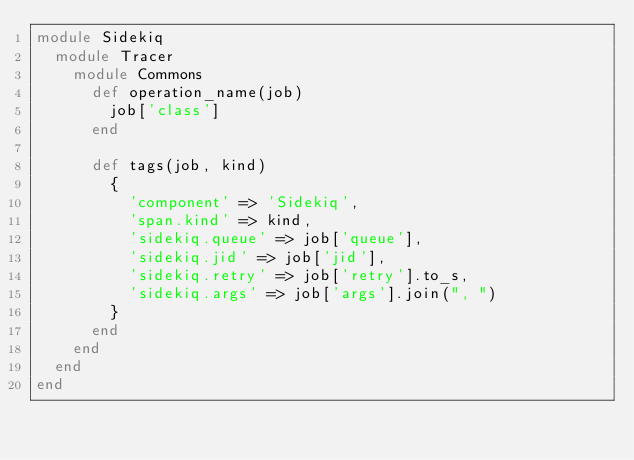<code> <loc_0><loc_0><loc_500><loc_500><_Ruby_>module Sidekiq
  module Tracer
    module Commons
      def operation_name(job)
        job['class']
      end

      def tags(job, kind)
        {
          'component' => 'Sidekiq',
          'span.kind' => kind,
          'sidekiq.queue' => job['queue'],
          'sidekiq.jid' => job['jid'],
          'sidekiq.retry' => job['retry'].to_s,
          'sidekiq.args' => job['args'].join(", ")
        }
      end
    end
  end
end
</code> 